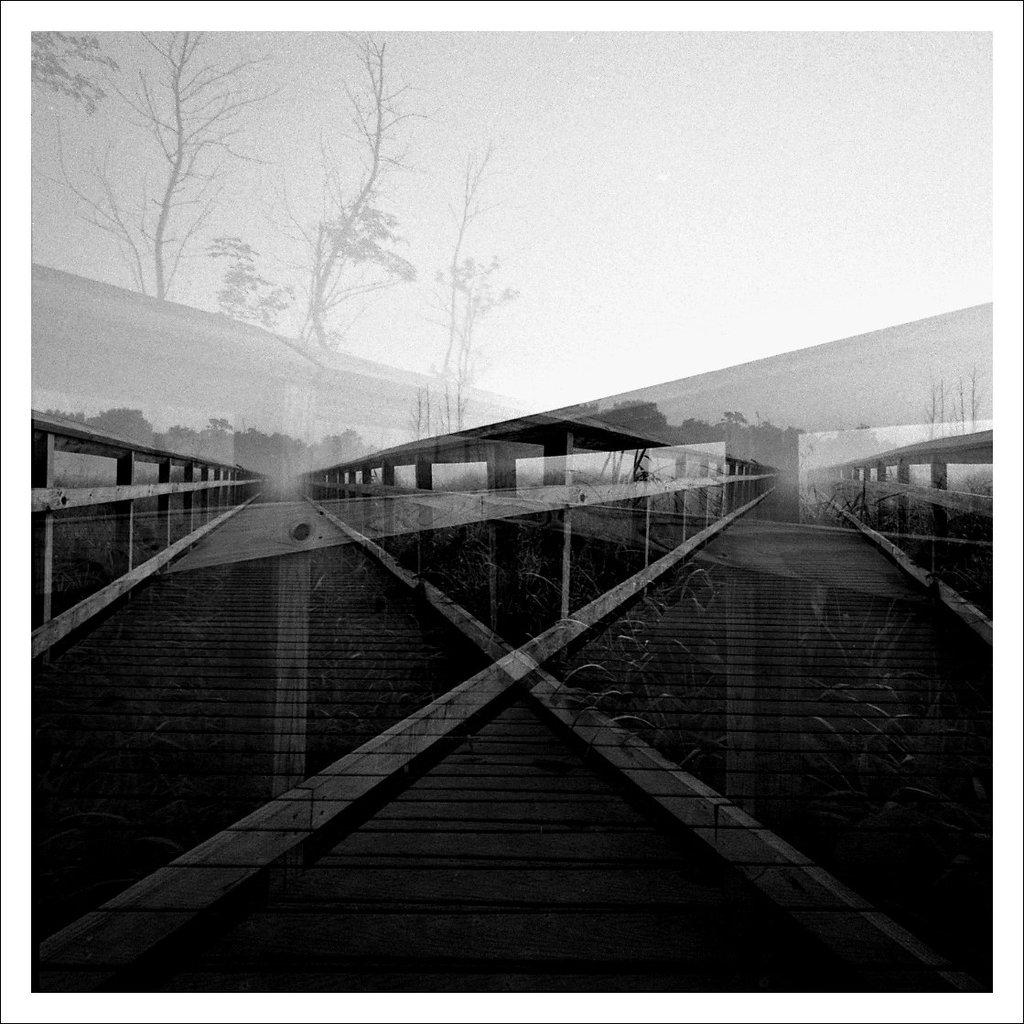What is the color scheme of the image? The image is black and white and edited. What can be seen on the platform in the image? There are railings in the image. What type of vegetation is present in the image? There are plants in the image. What is visible in the background of the image? There are trees and the sky in the background of the image. Can you see any clover growing on the platform in the image? There is no clover visible in the image. How many people are pushing the platform in the image? There are no people present in the image, and therefore no one is pushing the platform. 